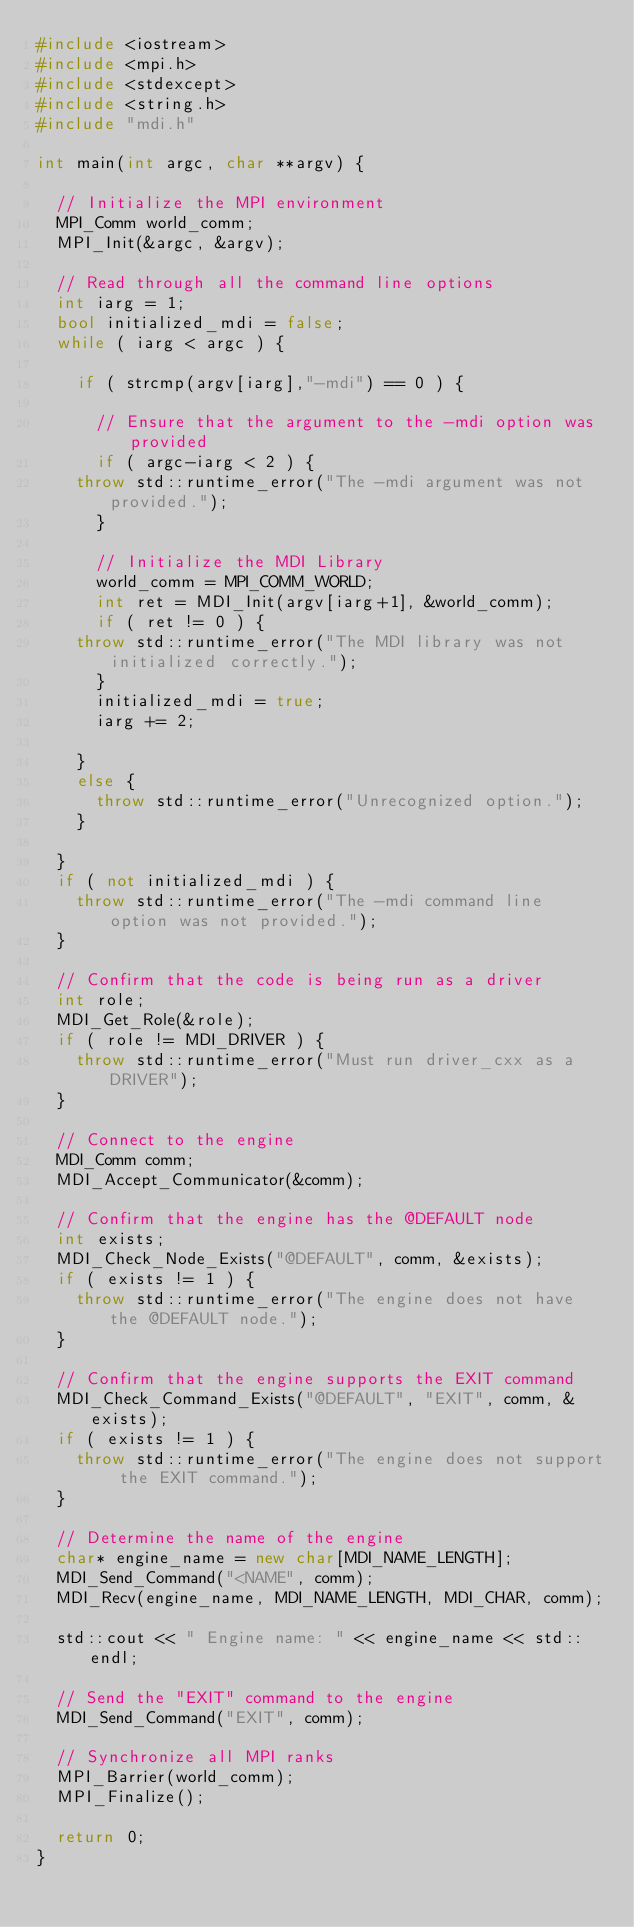<code> <loc_0><loc_0><loc_500><loc_500><_C++_>#include <iostream>
#include <mpi.h>
#include <stdexcept>
#include <string.h>
#include "mdi.h"

int main(int argc, char **argv) {

  // Initialize the MPI environment
  MPI_Comm world_comm;
  MPI_Init(&argc, &argv);

  // Read through all the command line options
  int iarg = 1;
  bool initialized_mdi = false;
  while ( iarg < argc ) {

    if ( strcmp(argv[iarg],"-mdi") == 0 ) {

      // Ensure that the argument to the -mdi option was provided
      if ( argc-iarg < 2 ) {
	throw std::runtime_error("The -mdi argument was not provided.");
      }

      // Initialize the MDI Library
      world_comm = MPI_COMM_WORLD;
      int ret = MDI_Init(argv[iarg+1], &world_comm);
      if ( ret != 0 ) {
	throw std::runtime_error("The MDI library was not initialized correctly.");
      }
      initialized_mdi = true;
      iarg += 2;

    }
    else {
      throw std::runtime_error("Unrecognized option.");
    }

  }
  if ( not initialized_mdi ) {
    throw std::runtime_error("The -mdi command line option was not provided.");
  }

  // Confirm that the code is being run as a driver
  int role;
  MDI_Get_Role(&role);
  if ( role != MDI_DRIVER ) {
    throw std::runtime_error("Must run driver_cxx as a DRIVER");
  }

  // Connect to the engine
  MDI_Comm comm;
  MDI_Accept_Communicator(&comm);

  // Confirm that the engine has the @DEFAULT node
  int exists;
  MDI_Check_Node_Exists("@DEFAULT", comm, &exists);
  if ( exists != 1 ) {
    throw std::runtime_error("The engine does not have the @DEFAULT node.");
  }

  // Confirm that the engine supports the EXIT command
  MDI_Check_Command_Exists("@DEFAULT", "EXIT", comm, &exists);
  if ( exists != 1 ) {
    throw std::runtime_error("The engine does not support the EXIT command.");
  }

  // Determine the name of the engine
  char* engine_name = new char[MDI_NAME_LENGTH];
  MDI_Send_Command("<NAME", comm);
  MDI_Recv(engine_name, MDI_NAME_LENGTH, MDI_CHAR, comm);

  std::cout << " Engine name: " << engine_name << std::endl;

  // Send the "EXIT" command to the engine
  MDI_Send_Command("EXIT", comm);

  // Synchronize all MPI ranks
  MPI_Barrier(world_comm);
  MPI_Finalize();

  return 0;
}
</code> 